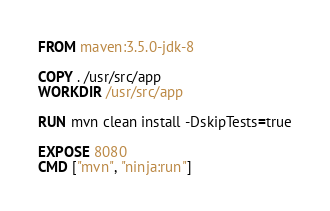<code> <loc_0><loc_0><loc_500><loc_500><_Dockerfile_>FROM maven:3.5.0-jdk-8

COPY . /usr/src/app
WORKDIR /usr/src/app

RUN mvn clean install -DskipTests=true

EXPOSE 8080
CMD ["mvn", "ninja:run"]
</code> 